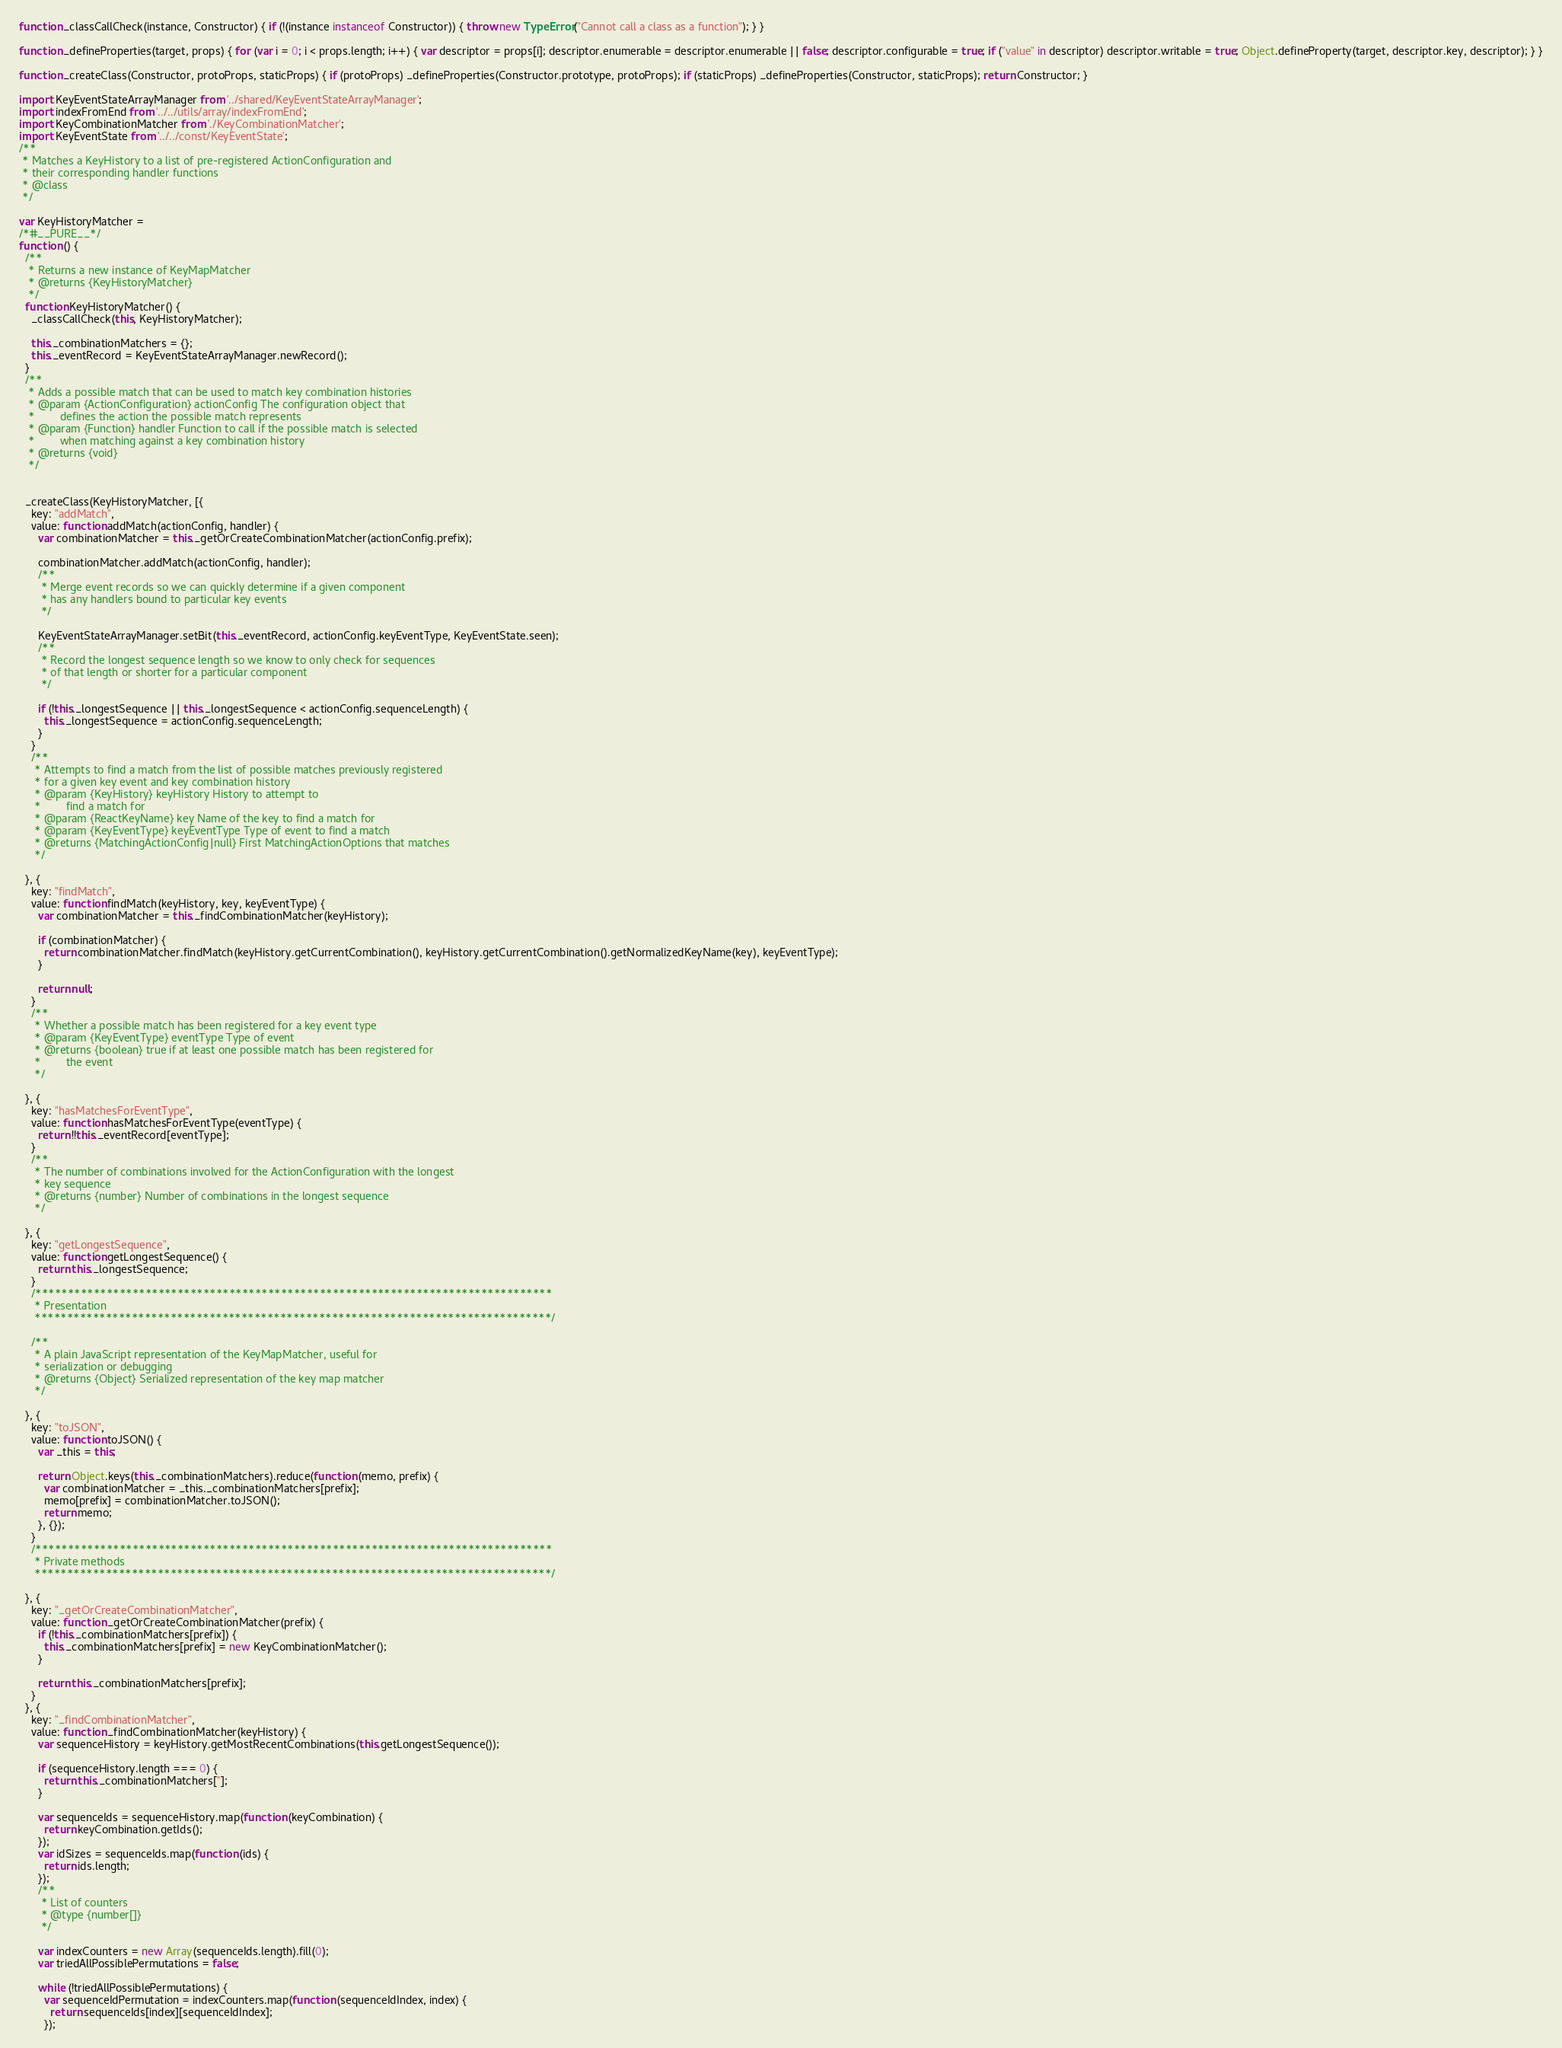<code> <loc_0><loc_0><loc_500><loc_500><_JavaScript_>function _classCallCheck(instance, Constructor) { if (!(instance instanceof Constructor)) { throw new TypeError("Cannot call a class as a function"); } }

function _defineProperties(target, props) { for (var i = 0; i < props.length; i++) { var descriptor = props[i]; descriptor.enumerable = descriptor.enumerable || false; descriptor.configurable = true; if ("value" in descriptor) descriptor.writable = true; Object.defineProperty(target, descriptor.key, descriptor); } }

function _createClass(Constructor, protoProps, staticProps) { if (protoProps) _defineProperties(Constructor.prototype, protoProps); if (staticProps) _defineProperties(Constructor, staticProps); return Constructor; }

import KeyEventStateArrayManager from '../shared/KeyEventStateArrayManager';
import indexFromEnd from '../../utils/array/indexFromEnd';
import KeyCombinationMatcher from './KeyCombinationMatcher';
import KeyEventState from '../../const/KeyEventState';
/**
 * Matches a KeyHistory to a list of pre-registered ActionConfiguration and
 * their corresponding handler functions
 * @class
 */

var KeyHistoryMatcher =
/*#__PURE__*/
function () {
  /**
   * Returns a new instance of KeyMapMatcher
   * @returns {KeyHistoryMatcher}
   */
  function KeyHistoryMatcher() {
    _classCallCheck(this, KeyHistoryMatcher);

    this._combinationMatchers = {};
    this._eventRecord = KeyEventStateArrayManager.newRecord();
  }
  /**
   * Adds a possible match that can be used to match key combination histories
   * @param {ActionConfiguration} actionConfig The configuration object that
   *        defines the action the possible match represents
   * @param {Function} handler Function to call if the possible match is selected
   *        when matching against a key combination history
   * @returns {void}
   */


  _createClass(KeyHistoryMatcher, [{
    key: "addMatch",
    value: function addMatch(actionConfig, handler) {
      var combinationMatcher = this._getOrCreateCombinationMatcher(actionConfig.prefix);

      combinationMatcher.addMatch(actionConfig, handler);
      /**
       * Merge event records so we can quickly determine if a given component
       * has any handlers bound to particular key events
       */

      KeyEventStateArrayManager.setBit(this._eventRecord, actionConfig.keyEventType, KeyEventState.seen);
      /**
       * Record the longest sequence length so we know to only check for sequences
       * of that length or shorter for a particular component
       */

      if (!this._longestSequence || this._longestSequence < actionConfig.sequenceLength) {
        this._longestSequence = actionConfig.sequenceLength;
      }
    }
    /**
     * Attempts to find a match from the list of possible matches previously registered
     * for a given key event and key combination history
     * @param {KeyHistory} keyHistory History to attempt to
     *        find a match for
     * @param {ReactKeyName} key Name of the key to find a match for
     * @param {KeyEventType} keyEventType Type of event to find a match
     * @returns {MatchingActionConfig|null} First MatchingActionOptions that matches
     */

  }, {
    key: "findMatch",
    value: function findMatch(keyHistory, key, keyEventType) {
      var combinationMatcher = this._findCombinationMatcher(keyHistory);

      if (combinationMatcher) {
        return combinationMatcher.findMatch(keyHistory.getCurrentCombination(), keyHistory.getCurrentCombination().getNormalizedKeyName(key), keyEventType);
      }

      return null;
    }
    /**
     * Whether a possible match has been registered for a key event type
     * @param {KeyEventType} eventType Type of event
     * @returns {boolean} true if at least one possible match has been registered for
     *        the event
     */

  }, {
    key: "hasMatchesForEventType",
    value: function hasMatchesForEventType(eventType) {
      return !!this._eventRecord[eventType];
    }
    /**
     * The number of combinations involved for the ActionConfiguration with the longest
     * key sequence
     * @returns {number} Number of combinations in the longest sequence
     */

  }, {
    key: "getLongestSequence",
    value: function getLongestSequence() {
      return this._longestSequence;
    }
    /********************************************************************************
     * Presentation
     ********************************************************************************/

    /**
     * A plain JavaScript representation of the KeyMapMatcher, useful for
     * serialization or debugging
     * @returns {Object} Serialized representation of the key map matcher
     */

  }, {
    key: "toJSON",
    value: function toJSON() {
      var _this = this;

      return Object.keys(this._combinationMatchers).reduce(function (memo, prefix) {
        var combinationMatcher = _this._combinationMatchers[prefix];
        memo[prefix] = combinationMatcher.toJSON();
        return memo;
      }, {});
    }
    /********************************************************************************
     * Private methods
     ********************************************************************************/

  }, {
    key: "_getOrCreateCombinationMatcher",
    value: function _getOrCreateCombinationMatcher(prefix) {
      if (!this._combinationMatchers[prefix]) {
        this._combinationMatchers[prefix] = new KeyCombinationMatcher();
      }

      return this._combinationMatchers[prefix];
    }
  }, {
    key: "_findCombinationMatcher",
    value: function _findCombinationMatcher(keyHistory) {
      var sequenceHistory = keyHistory.getMostRecentCombinations(this.getLongestSequence());

      if (sequenceHistory.length === 0) {
        return this._combinationMatchers[''];
      }

      var sequenceIds = sequenceHistory.map(function (keyCombination) {
        return keyCombination.getIds();
      });
      var idSizes = sequenceIds.map(function (ids) {
        return ids.length;
      });
      /**
       * List of counters
       * @type {number[]}
       */

      var indexCounters = new Array(sequenceIds.length).fill(0);
      var triedAllPossiblePermutations = false;

      while (!triedAllPossiblePermutations) {
        var sequenceIdPermutation = indexCounters.map(function (sequenceIdIndex, index) {
          return sequenceIds[index][sequenceIdIndex];
        });</code> 